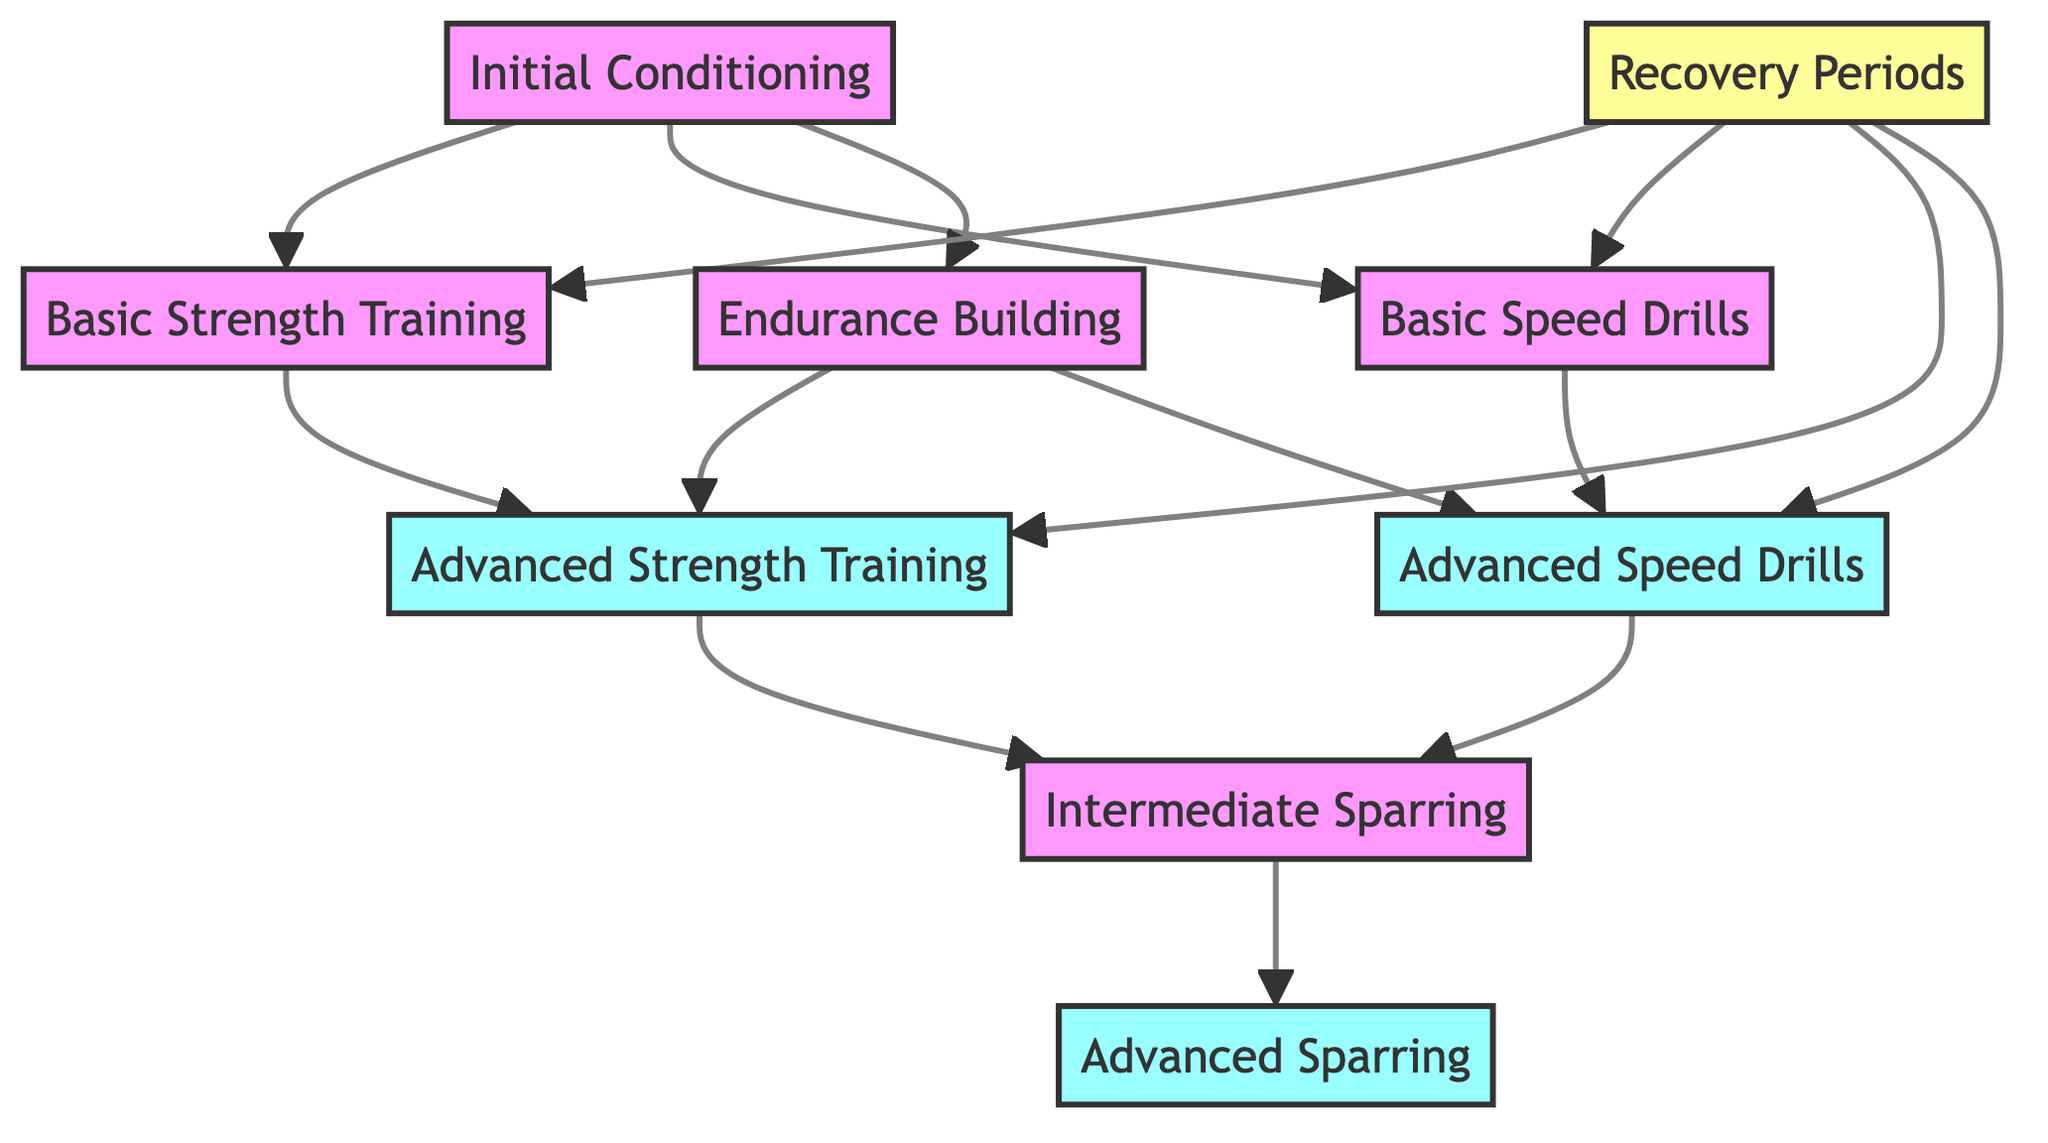What is the first step in the training schedule? The first step represented in the diagram is "Initial Conditioning," which is the starting point from which all other training activities branch out.
Answer: Initial Conditioning How many nodes are there in the graph? The diagram consists of 9 distinct nodes, each representing a different stage or activity in the training regimen.
Answer: 9 Which node directly leads to both "Basic Speed Drills" and "Basic Strength Training"? "Initial Conditioning" is the only node that directly connects to both of these nodes, serving as the entry point to further training activities.
Answer: Initial Conditioning What is the final step in the training schedule? The final step in the progression is "Advanced Sparring," which is the end point for the advanced training cycle.
Answer: Advanced Sparring How many edges come out of "Recovery Periods"? There are 4 edges emanating from "Recovery Periods," indicating that recovery can lead to various training activities like strength training, speed drills, and advanced training.
Answer: 4 Which step follows "Endurance Building"? "Endurance Building" can lead to both "Advanced Strength Training" and "Advanced Speed Drills," making those the next steps following it.
Answer: Advanced Strength Training and Advanced Speed Drills What is one training activity that leads to "Intermediate Sparring"? Both "Advanced Strength Training" and "Advanced Speed Drills" lead to "Intermediate Sparring," indicating the progression from advanced training to sparring practice.
Answer: Advanced Strength Training or Advanced Speed Drills Does "Recovery Periods" contribute to the training cycle? Yes, "Recovery Periods" plays an integral role in the training cycle by allowing for regeneration and branching into various training activities.
Answer: Yes Which node has the most outgoing edges? "Initial Conditioning" has the most outgoing edges, linking to three separate training activities: Basic Strength Training, Basic Speed Drills, and Endurance Building.
Answer: Initial Conditioning 